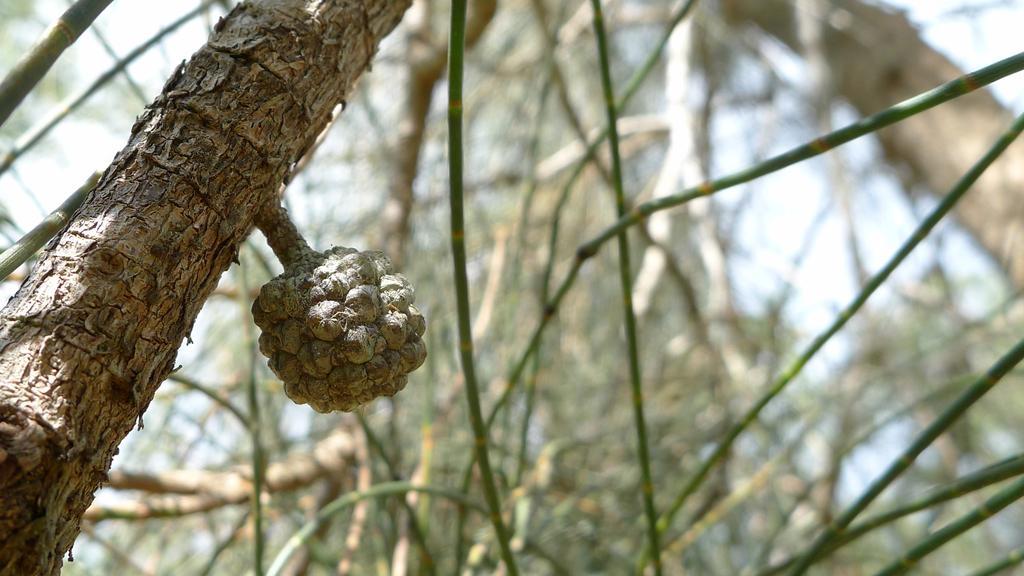How would you summarize this image in a sentence or two? In this image I can see a trunk, background I can see trees in green color and the sky is in white color. 